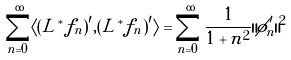<formula> <loc_0><loc_0><loc_500><loc_500>\sum _ { n = 0 } ^ { \infty } \langle ( L ^ { * } f _ { n } ) ^ { \prime } , ( L ^ { * } f _ { n } ) ^ { \prime } \rangle = \sum _ { n = 0 } ^ { \infty } \frac { 1 } { 1 + n ^ { 2 } } \| \tilde { \phi } ^ { \prime } _ { n } \| ^ { 2 }</formula> 